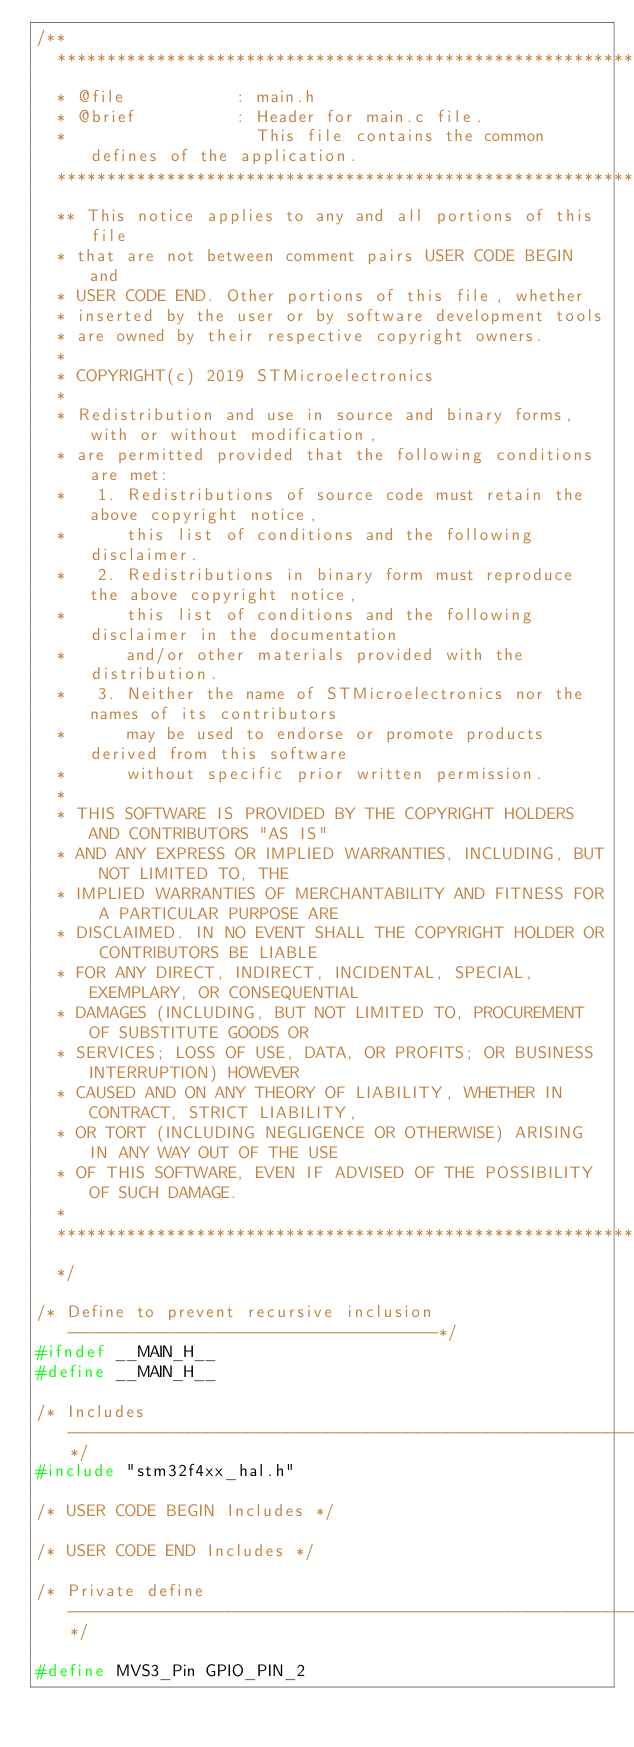<code> <loc_0><loc_0><loc_500><loc_500><_C_>/**
  ******************************************************************************
  * @file           : main.h
  * @brief          : Header for main.c file.
  *                   This file contains the common defines of the application.
  ******************************************************************************
  ** This notice applies to any and all portions of this file
  * that are not between comment pairs USER CODE BEGIN and
  * USER CODE END. Other portions of this file, whether 
  * inserted by the user or by software development tools
  * are owned by their respective copyright owners.
  *
  * COPYRIGHT(c) 2019 STMicroelectronics
  *
  * Redistribution and use in source and binary forms, with or without modification,
  * are permitted provided that the following conditions are met:
  *   1. Redistributions of source code must retain the above copyright notice,
  *      this list of conditions and the following disclaimer.
  *   2. Redistributions in binary form must reproduce the above copyright notice,
  *      this list of conditions and the following disclaimer in the documentation
  *      and/or other materials provided with the distribution.
  *   3. Neither the name of STMicroelectronics nor the names of its contributors
  *      may be used to endorse or promote products derived from this software
  *      without specific prior written permission.
  *
  * THIS SOFTWARE IS PROVIDED BY THE COPYRIGHT HOLDERS AND CONTRIBUTORS "AS IS"
  * AND ANY EXPRESS OR IMPLIED WARRANTIES, INCLUDING, BUT NOT LIMITED TO, THE
  * IMPLIED WARRANTIES OF MERCHANTABILITY AND FITNESS FOR A PARTICULAR PURPOSE ARE
  * DISCLAIMED. IN NO EVENT SHALL THE COPYRIGHT HOLDER OR CONTRIBUTORS BE LIABLE
  * FOR ANY DIRECT, INDIRECT, INCIDENTAL, SPECIAL, EXEMPLARY, OR CONSEQUENTIAL
  * DAMAGES (INCLUDING, BUT NOT LIMITED TO, PROCUREMENT OF SUBSTITUTE GOODS OR
  * SERVICES; LOSS OF USE, DATA, OR PROFITS; OR BUSINESS INTERRUPTION) HOWEVER
  * CAUSED AND ON ANY THEORY OF LIABILITY, WHETHER IN CONTRACT, STRICT LIABILITY,
  * OR TORT (INCLUDING NEGLIGENCE OR OTHERWISE) ARISING IN ANY WAY OUT OF THE USE
  * OF THIS SOFTWARE, EVEN IF ADVISED OF THE POSSIBILITY OF SUCH DAMAGE.
  *
  ******************************************************************************
  */

/* Define to prevent recursive inclusion -------------------------------------*/
#ifndef __MAIN_H__
#define __MAIN_H__

/* Includes ------------------------------------------------------------------*/
#include "stm32f4xx_hal.h"

/* USER CODE BEGIN Includes */

/* USER CODE END Includes */

/* Private define ------------------------------------------------------------*/

#define MVS3_Pin GPIO_PIN_2</code> 